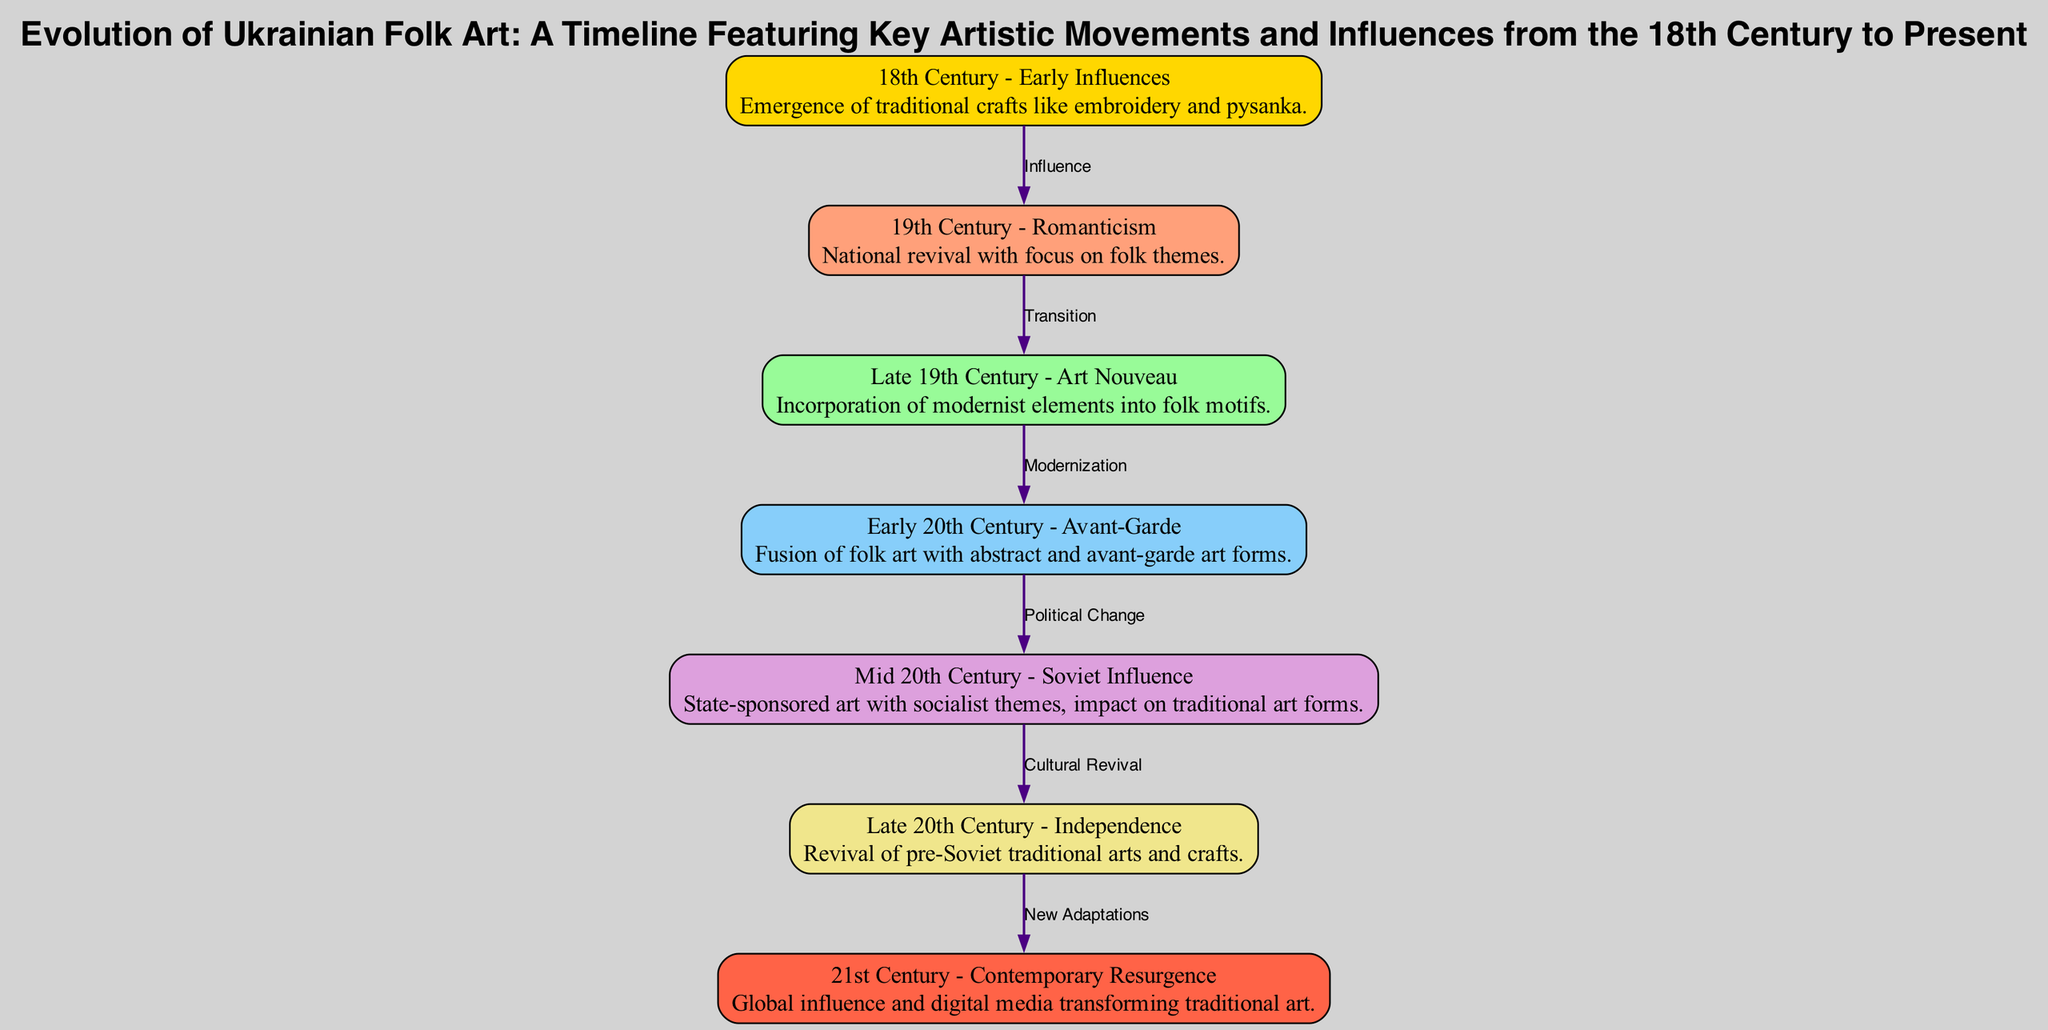What is the earliest artistic movement depicted in the diagram? The diagram shows "18th Century - Early Influences" as the first node, indicating it is the earliest artistic movement represented in the timeline.
Answer: 18th Century - Early Influences Which artistic movement is characterized by state-sponsored art with socialist themes? The node labeled "Mid 20th Century - Soviet Influence" describes the impact of state-sponsored art which had socialist themes, making it the correct answer.
Answer: Mid 20th Century - Soviet Influence How many total nodes are present in the diagram? By counting the nodes listed in the diagram, there are seven nodes that illustrate different periods in the evolution of Ukrainian folk art.
Answer: 7 What was the influence that connected the 19th Century movement to the Late 19th Century movement? The edge between the nodes for the 19th Century and Late 19th Century is labeled "Transition," indicating the relationship between these two movements.
Answer: Transition Describe the relationship between Early 20th Century and Mid 20th Century movements. The arrow connecting these two nodes is labeled "Political Change," highlighting that the transition from the avant-garde influenced by abstract forms to Soviet restrictions was marked by significant political changes.
Answer: Political Change What artistic movement emerged as a response to the independence of Ukraine in the late 20th century? The node titled "Late 20th Century - Independence" indicates a revival of pre-Soviet traditional arts in response to Ukraine's independence, marking the artistic movement that emerged during this time.
Answer: Late 20th Century - Independence What new adaptations are highlighted in the 21st Century? The description for the node labeled "21st Century - Contemporary Resurgence" outlines global influence and digital media transforming traditional art, which refers to these adaptations.
Answer: New Adaptations What color represents the 19th Century - Romanticism movement in the diagram? The 19th Century - Romanticism node is filled with the color "#FFA07A," which is a soft salmon shade, representing this artistic movement visually in the diagram.
Answer: #FFA07A 